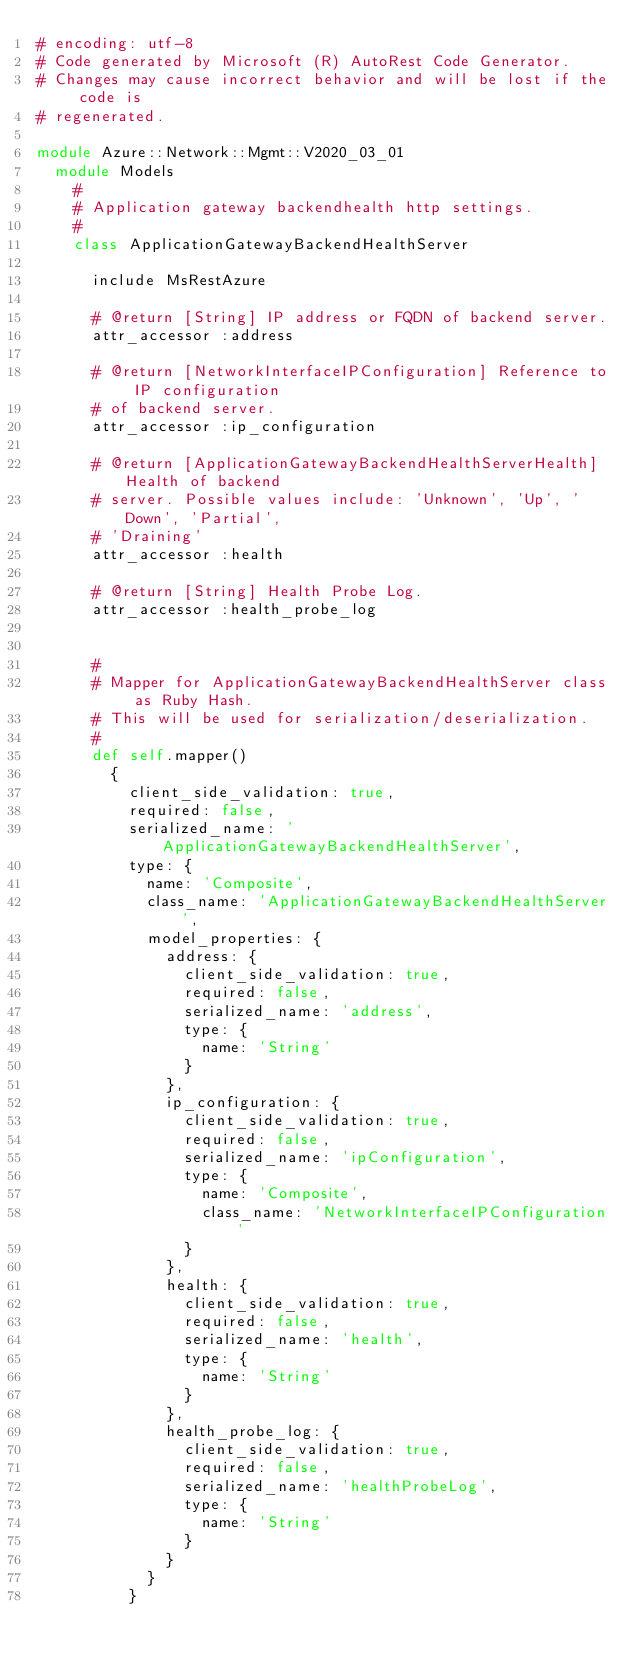Convert code to text. <code><loc_0><loc_0><loc_500><loc_500><_Ruby_># encoding: utf-8
# Code generated by Microsoft (R) AutoRest Code Generator.
# Changes may cause incorrect behavior and will be lost if the code is
# regenerated.

module Azure::Network::Mgmt::V2020_03_01
  module Models
    #
    # Application gateway backendhealth http settings.
    #
    class ApplicationGatewayBackendHealthServer

      include MsRestAzure

      # @return [String] IP address or FQDN of backend server.
      attr_accessor :address

      # @return [NetworkInterfaceIPConfiguration] Reference to IP configuration
      # of backend server.
      attr_accessor :ip_configuration

      # @return [ApplicationGatewayBackendHealthServerHealth] Health of backend
      # server. Possible values include: 'Unknown', 'Up', 'Down', 'Partial',
      # 'Draining'
      attr_accessor :health

      # @return [String] Health Probe Log.
      attr_accessor :health_probe_log


      #
      # Mapper for ApplicationGatewayBackendHealthServer class as Ruby Hash.
      # This will be used for serialization/deserialization.
      #
      def self.mapper()
        {
          client_side_validation: true,
          required: false,
          serialized_name: 'ApplicationGatewayBackendHealthServer',
          type: {
            name: 'Composite',
            class_name: 'ApplicationGatewayBackendHealthServer',
            model_properties: {
              address: {
                client_side_validation: true,
                required: false,
                serialized_name: 'address',
                type: {
                  name: 'String'
                }
              },
              ip_configuration: {
                client_side_validation: true,
                required: false,
                serialized_name: 'ipConfiguration',
                type: {
                  name: 'Composite',
                  class_name: 'NetworkInterfaceIPConfiguration'
                }
              },
              health: {
                client_side_validation: true,
                required: false,
                serialized_name: 'health',
                type: {
                  name: 'String'
                }
              },
              health_probe_log: {
                client_side_validation: true,
                required: false,
                serialized_name: 'healthProbeLog',
                type: {
                  name: 'String'
                }
              }
            }
          }</code> 